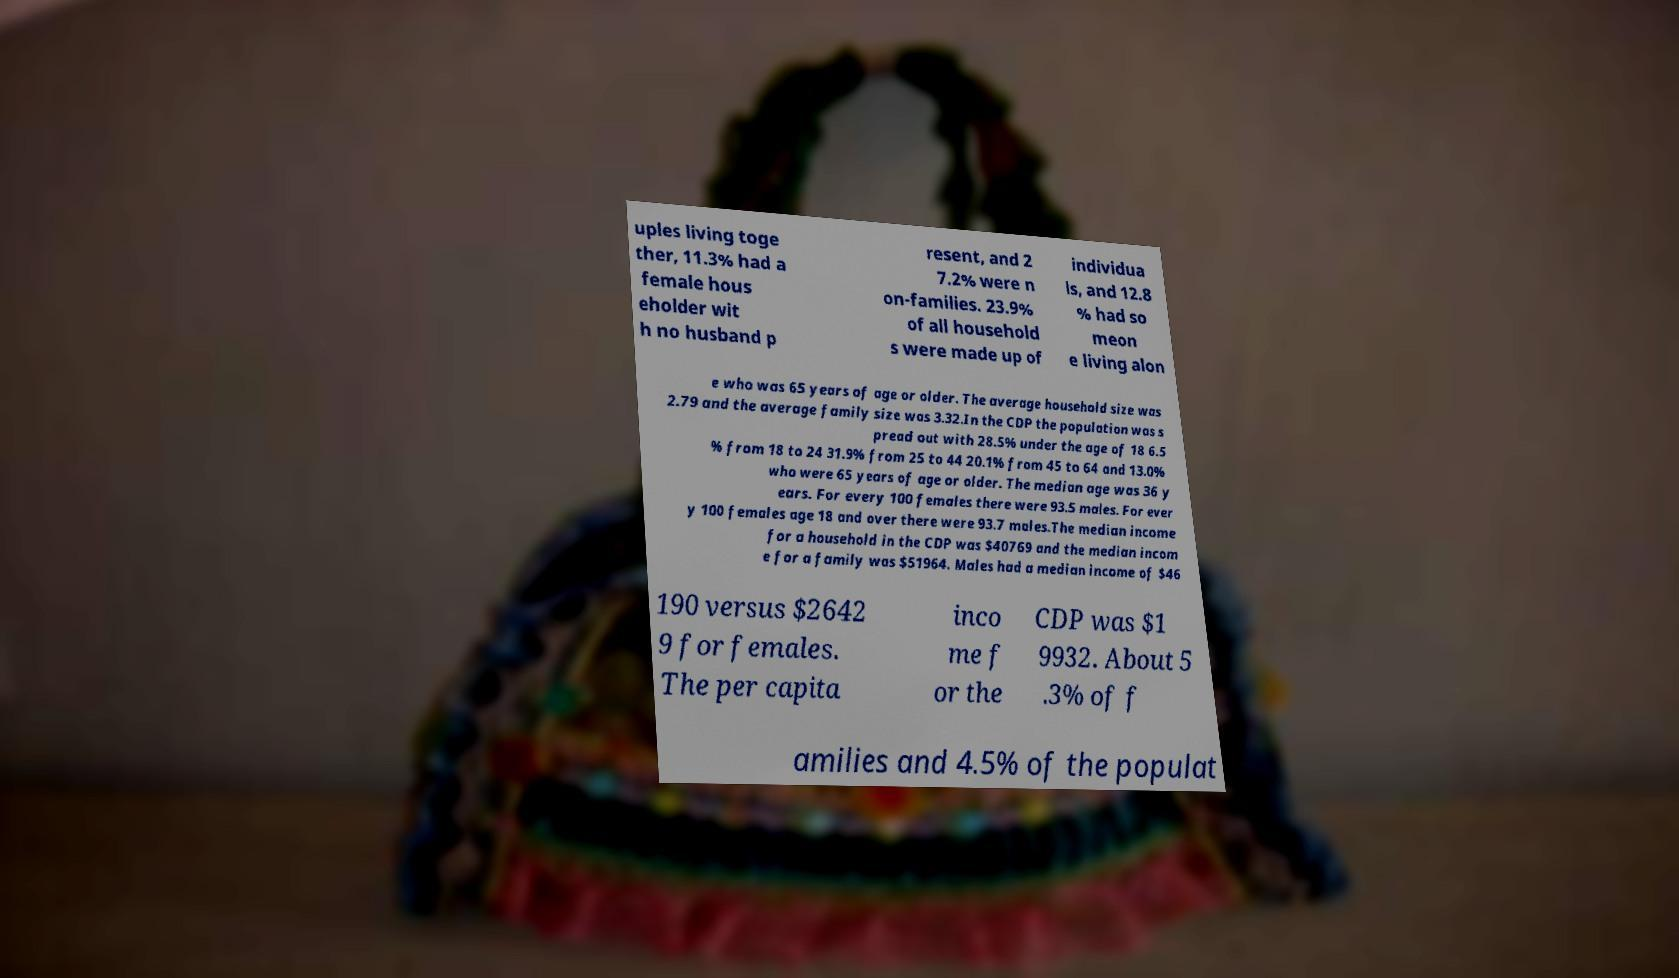Please read and relay the text visible in this image. What does it say? uples living toge ther, 11.3% had a female hous eholder wit h no husband p resent, and 2 7.2% were n on-families. 23.9% of all household s were made up of individua ls, and 12.8 % had so meon e living alon e who was 65 years of age or older. The average household size was 2.79 and the average family size was 3.32.In the CDP the population was s pread out with 28.5% under the age of 18 6.5 % from 18 to 24 31.9% from 25 to 44 20.1% from 45 to 64 and 13.0% who were 65 years of age or older. The median age was 36 y ears. For every 100 females there were 93.5 males. For ever y 100 females age 18 and over there were 93.7 males.The median income for a household in the CDP was $40769 and the median incom e for a family was $51964. Males had a median income of $46 190 versus $2642 9 for females. The per capita inco me f or the CDP was $1 9932. About 5 .3% of f amilies and 4.5% of the populat 